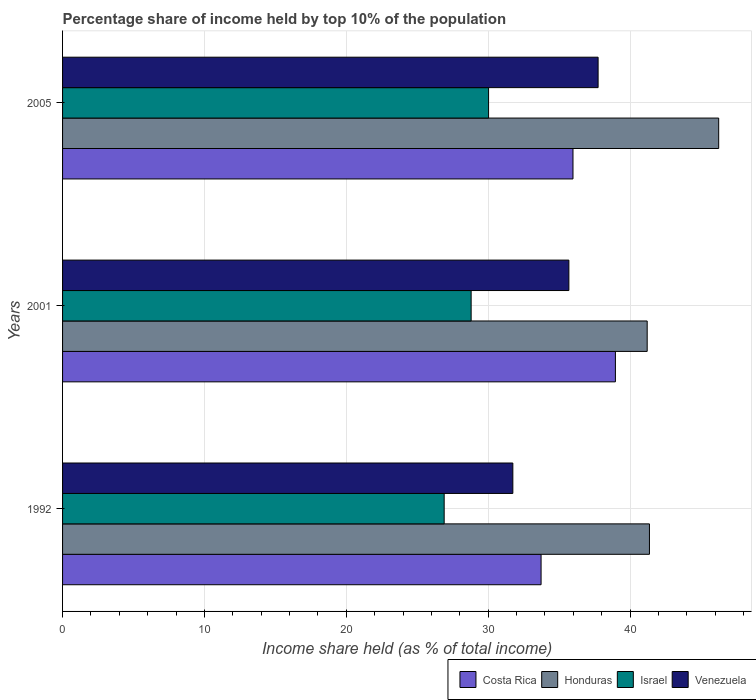How many different coloured bars are there?
Ensure brevity in your answer.  4. Are the number of bars per tick equal to the number of legend labels?
Your answer should be very brief. Yes. Are the number of bars on each tick of the Y-axis equal?
Your answer should be compact. Yes. In how many cases, is the number of bars for a given year not equal to the number of legend labels?
Offer a very short reply. 0. What is the percentage share of income held by top 10% of the population in Costa Rica in 2005?
Give a very brief answer. 35.98. Across all years, what is the maximum percentage share of income held by top 10% of the population in Costa Rica?
Make the answer very short. 38.97. Across all years, what is the minimum percentage share of income held by top 10% of the population in Venezuela?
Provide a short and direct response. 31.74. What is the total percentage share of income held by top 10% of the population in Israel in the graph?
Your answer should be compact. 85.73. What is the difference between the percentage share of income held by top 10% of the population in Venezuela in 1992 and that in 2005?
Provide a short and direct response. -6.01. What is the difference between the percentage share of income held by top 10% of the population in Honduras in 2005 and the percentage share of income held by top 10% of the population in Venezuela in 2001?
Ensure brevity in your answer.  10.56. What is the average percentage share of income held by top 10% of the population in Venezuela per year?
Make the answer very short. 35.06. In the year 2001, what is the difference between the percentage share of income held by top 10% of the population in Honduras and percentage share of income held by top 10% of the population in Costa Rica?
Provide a succinct answer. 2.24. In how many years, is the percentage share of income held by top 10% of the population in Venezuela greater than 44 %?
Your response must be concise. 0. What is the ratio of the percentage share of income held by top 10% of the population in Israel in 1992 to that in 2005?
Offer a terse response. 0.9. What is the difference between the highest and the second highest percentage share of income held by top 10% of the population in Costa Rica?
Provide a succinct answer. 2.99. What is the difference between the highest and the lowest percentage share of income held by top 10% of the population in Costa Rica?
Offer a very short reply. 5.24. Is it the case that in every year, the sum of the percentage share of income held by top 10% of the population in Venezuela and percentage share of income held by top 10% of the population in Israel is greater than the sum of percentage share of income held by top 10% of the population in Costa Rica and percentage share of income held by top 10% of the population in Honduras?
Offer a very short reply. No. What does the 3rd bar from the top in 1992 represents?
Your response must be concise. Honduras. What does the 4th bar from the bottom in 2001 represents?
Make the answer very short. Venezuela. How many bars are there?
Your answer should be compact. 12. How many years are there in the graph?
Your response must be concise. 3. Are the values on the major ticks of X-axis written in scientific E-notation?
Your response must be concise. No. Does the graph contain any zero values?
Give a very brief answer. No. What is the title of the graph?
Give a very brief answer. Percentage share of income held by top 10% of the population. Does "World" appear as one of the legend labels in the graph?
Offer a very short reply. No. What is the label or title of the X-axis?
Make the answer very short. Income share held (as % of total income). What is the label or title of the Y-axis?
Give a very brief answer. Years. What is the Income share held (as % of total income) in Costa Rica in 1992?
Provide a short and direct response. 33.73. What is the Income share held (as % of total income) of Honduras in 1992?
Provide a succinct answer. 41.37. What is the Income share held (as % of total income) in Israel in 1992?
Offer a very short reply. 26.9. What is the Income share held (as % of total income) in Venezuela in 1992?
Ensure brevity in your answer.  31.74. What is the Income share held (as % of total income) in Costa Rica in 2001?
Make the answer very short. 38.97. What is the Income share held (as % of total income) of Honduras in 2001?
Provide a succinct answer. 41.21. What is the Income share held (as % of total income) of Israel in 2001?
Offer a very short reply. 28.8. What is the Income share held (as % of total income) in Venezuela in 2001?
Offer a very short reply. 35.69. What is the Income share held (as % of total income) of Costa Rica in 2005?
Offer a terse response. 35.98. What is the Income share held (as % of total income) of Honduras in 2005?
Give a very brief answer. 46.25. What is the Income share held (as % of total income) of Israel in 2005?
Offer a very short reply. 30.03. What is the Income share held (as % of total income) of Venezuela in 2005?
Your response must be concise. 37.75. Across all years, what is the maximum Income share held (as % of total income) of Costa Rica?
Provide a short and direct response. 38.97. Across all years, what is the maximum Income share held (as % of total income) of Honduras?
Keep it short and to the point. 46.25. Across all years, what is the maximum Income share held (as % of total income) of Israel?
Give a very brief answer. 30.03. Across all years, what is the maximum Income share held (as % of total income) of Venezuela?
Your response must be concise. 37.75. Across all years, what is the minimum Income share held (as % of total income) of Costa Rica?
Your answer should be compact. 33.73. Across all years, what is the minimum Income share held (as % of total income) in Honduras?
Make the answer very short. 41.21. Across all years, what is the minimum Income share held (as % of total income) of Israel?
Your answer should be compact. 26.9. Across all years, what is the minimum Income share held (as % of total income) of Venezuela?
Offer a terse response. 31.74. What is the total Income share held (as % of total income) of Costa Rica in the graph?
Provide a short and direct response. 108.68. What is the total Income share held (as % of total income) in Honduras in the graph?
Provide a succinct answer. 128.83. What is the total Income share held (as % of total income) in Israel in the graph?
Provide a short and direct response. 85.73. What is the total Income share held (as % of total income) of Venezuela in the graph?
Give a very brief answer. 105.18. What is the difference between the Income share held (as % of total income) of Costa Rica in 1992 and that in 2001?
Your answer should be very brief. -5.24. What is the difference between the Income share held (as % of total income) of Honduras in 1992 and that in 2001?
Ensure brevity in your answer.  0.16. What is the difference between the Income share held (as % of total income) in Venezuela in 1992 and that in 2001?
Provide a succinct answer. -3.95. What is the difference between the Income share held (as % of total income) in Costa Rica in 1992 and that in 2005?
Keep it short and to the point. -2.25. What is the difference between the Income share held (as % of total income) in Honduras in 1992 and that in 2005?
Provide a short and direct response. -4.88. What is the difference between the Income share held (as % of total income) of Israel in 1992 and that in 2005?
Provide a succinct answer. -3.13. What is the difference between the Income share held (as % of total income) of Venezuela in 1992 and that in 2005?
Offer a very short reply. -6.01. What is the difference between the Income share held (as % of total income) in Costa Rica in 2001 and that in 2005?
Keep it short and to the point. 2.99. What is the difference between the Income share held (as % of total income) in Honduras in 2001 and that in 2005?
Ensure brevity in your answer.  -5.04. What is the difference between the Income share held (as % of total income) in Israel in 2001 and that in 2005?
Make the answer very short. -1.23. What is the difference between the Income share held (as % of total income) of Venezuela in 2001 and that in 2005?
Offer a very short reply. -2.06. What is the difference between the Income share held (as % of total income) in Costa Rica in 1992 and the Income share held (as % of total income) in Honduras in 2001?
Provide a short and direct response. -7.48. What is the difference between the Income share held (as % of total income) of Costa Rica in 1992 and the Income share held (as % of total income) of Israel in 2001?
Your answer should be very brief. 4.93. What is the difference between the Income share held (as % of total income) in Costa Rica in 1992 and the Income share held (as % of total income) in Venezuela in 2001?
Provide a succinct answer. -1.96. What is the difference between the Income share held (as % of total income) of Honduras in 1992 and the Income share held (as % of total income) of Israel in 2001?
Provide a succinct answer. 12.57. What is the difference between the Income share held (as % of total income) of Honduras in 1992 and the Income share held (as % of total income) of Venezuela in 2001?
Give a very brief answer. 5.68. What is the difference between the Income share held (as % of total income) of Israel in 1992 and the Income share held (as % of total income) of Venezuela in 2001?
Make the answer very short. -8.79. What is the difference between the Income share held (as % of total income) in Costa Rica in 1992 and the Income share held (as % of total income) in Honduras in 2005?
Your answer should be very brief. -12.52. What is the difference between the Income share held (as % of total income) of Costa Rica in 1992 and the Income share held (as % of total income) of Israel in 2005?
Provide a short and direct response. 3.7. What is the difference between the Income share held (as % of total income) in Costa Rica in 1992 and the Income share held (as % of total income) in Venezuela in 2005?
Offer a very short reply. -4.02. What is the difference between the Income share held (as % of total income) of Honduras in 1992 and the Income share held (as % of total income) of Israel in 2005?
Provide a short and direct response. 11.34. What is the difference between the Income share held (as % of total income) in Honduras in 1992 and the Income share held (as % of total income) in Venezuela in 2005?
Your answer should be compact. 3.62. What is the difference between the Income share held (as % of total income) in Israel in 1992 and the Income share held (as % of total income) in Venezuela in 2005?
Your answer should be very brief. -10.85. What is the difference between the Income share held (as % of total income) in Costa Rica in 2001 and the Income share held (as % of total income) in Honduras in 2005?
Give a very brief answer. -7.28. What is the difference between the Income share held (as % of total income) in Costa Rica in 2001 and the Income share held (as % of total income) in Israel in 2005?
Give a very brief answer. 8.94. What is the difference between the Income share held (as % of total income) in Costa Rica in 2001 and the Income share held (as % of total income) in Venezuela in 2005?
Give a very brief answer. 1.22. What is the difference between the Income share held (as % of total income) in Honduras in 2001 and the Income share held (as % of total income) in Israel in 2005?
Your answer should be compact. 11.18. What is the difference between the Income share held (as % of total income) of Honduras in 2001 and the Income share held (as % of total income) of Venezuela in 2005?
Your response must be concise. 3.46. What is the difference between the Income share held (as % of total income) in Israel in 2001 and the Income share held (as % of total income) in Venezuela in 2005?
Give a very brief answer. -8.95. What is the average Income share held (as % of total income) of Costa Rica per year?
Ensure brevity in your answer.  36.23. What is the average Income share held (as % of total income) in Honduras per year?
Give a very brief answer. 42.94. What is the average Income share held (as % of total income) in Israel per year?
Your response must be concise. 28.58. What is the average Income share held (as % of total income) of Venezuela per year?
Provide a succinct answer. 35.06. In the year 1992, what is the difference between the Income share held (as % of total income) of Costa Rica and Income share held (as % of total income) of Honduras?
Offer a very short reply. -7.64. In the year 1992, what is the difference between the Income share held (as % of total income) of Costa Rica and Income share held (as % of total income) of Israel?
Provide a short and direct response. 6.83. In the year 1992, what is the difference between the Income share held (as % of total income) in Costa Rica and Income share held (as % of total income) in Venezuela?
Offer a terse response. 1.99. In the year 1992, what is the difference between the Income share held (as % of total income) of Honduras and Income share held (as % of total income) of Israel?
Ensure brevity in your answer.  14.47. In the year 1992, what is the difference between the Income share held (as % of total income) of Honduras and Income share held (as % of total income) of Venezuela?
Your response must be concise. 9.63. In the year 1992, what is the difference between the Income share held (as % of total income) in Israel and Income share held (as % of total income) in Venezuela?
Your response must be concise. -4.84. In the year 2001, what is the difference between the Income share held (as % of total income) of Costa Rica and Income share held (as % of total income) of Honduras?
Offer a very short reply. -2.24. In the year 2001, what is the difference between the Income share held (as % of total income) of Costa Rica and Income share held (as % of total income) of Israel?
Provide a short and direct response. 10.17. In the year 2001, what is the difference between the Income share held (as % of total income) in Costa Rica and Income share held (as % of total income) in Venezuela?
Offer a very short reply. 3.28. In the year 2001, what is the difference between the Income share held (as % of total income) of Honduras and Income share held (as % of total income) of Israel?
Keep it short and to the point. 12.41. In the year 2001, what is the difference between the Income share held (as % of total income) of Honduras and Income share held (as % of total income) of Venezuela?
Give a very brief answer. 5.52. In the year 2001, what is the difference between the Income share held (as % of total income) of Israel and Income share held (as % of total income) of Venezuela?
Ensure brevity in your answer.  -6.89. In the year 2005, what is the difference between the Income share held (as % of total income) in Costa Rica and Income share held (as % of total income) in Honduras?
Offer a very short reply. -10.27. In the year 2005, what is the difference between the Income share held (as % of total income) in Costa Rica and Income share held (as % of total income) in Israel?
Provide a short and direct response. 5.95. In the year 2005, what is the difference between the Income share held (as % of total income) of Costa Rica and Income share held (as % of total income) of Venezuela?
Your answer should be compact. -1.77. In the year 2005, what is the difference between the Income share held (as % of total income) of Honduras and Income share held (as % of total income) of Israel?
Your response must be concise. 16.22. In the year 2005, what is the difference between the Income share held (as % of total income) in Honduras and Income share held (as % of total income) in Venezuela?
Your answer should be very brief. 8.5. In the year 2005, what is the difference between the Income share held (as % of total income) of Israel and Income share held (as % of total income) of Venezuela?
Your answer should be very brief. -7.72. What is the ratio of the Income share held (as % of total income) of Costa Rica in 1992 to that in 2001?
Your answer should be compact. 0.87. What is the ratio of the Income share held (as % of total income) in Honduras in 1992 to that in 2001?
Your answer should be compact. 1. What is the ratio of the Income share held (as % of total income) of Israel in 1992 to that in 2001?
Ensure brevity in your answer.  0.93. What is the ratio of the Income share held (as % of total income) in Venezuela in 1992 to that in 2001?
Keep it short and to the point. 0.89. What is the ratio of the Income share held (as % of total income) in Costa Rica in 1992 to that in 2005?
Provide a short and direct response. 0.94. What is the ratio of the Income share held (as % of total income) in Honduras in 1992 to that in 2005?
Keep it short and to the point. 0.89. What is the ratio of the Income share held (as % of total income) in Israel in 1992 to that in 2005?
Provide a succinct answer. 0.9. What is the ratio of the Income share held (as % of total income) in Venezuela in 1992 to that in 2005?
Make the answer very short. 0.84. What is the ratio of the Income share held (as % of total income) in Costa Rica in 2001 to that in 2005?
Your response must be concise. 1.08. What is the ratio of the Income share held (as % of total income) in Honduras in 2001 to that in 2005?
Your answer should be very brief. 0.89. What is the ratio of the Income share held (as % of total income) in Israel in 2001 to that in 2005?
Make the answer very short. 0.96. What is the ratio of the Income share held (as % of total income) in Venezuela in 2001 to that in 2005?
Keep it short and to the point. 0.95. What is the difference between the highest and the second highest Income share held (as % of total income) of Costa Rica?
Make the answer very short. 2.99. What is the difference between the highest and the second highest Income share held (as % of total income) in Honduras?
Offer a terse response. 4.88. What is the difference between the highest and the second highest Income share held (as % of total income) of Israel?
Offer a terse response. 1.23. What is the difference between the highest and the second highest Income share held (as % of total income) of Venezuela?
Provide a short and direct response. 2.06. What is the difference between the highest and the lowest Income share held (as % of total income) in Costa Rica?
Provide a short and direct response. 5.24. What is the difference between the highest and the lowest Income share held (as % of total income) in Honduras?
Your answer should be compact. 5.04. What is the difference between the highest and the lowest Income share held (as % of total income) of Israel?
Offer a terse response. 3.13. What is the difference between the highest and the lowest Income share held (as % of total income) of Venezuela?
Offer a terse response. 6.01. 